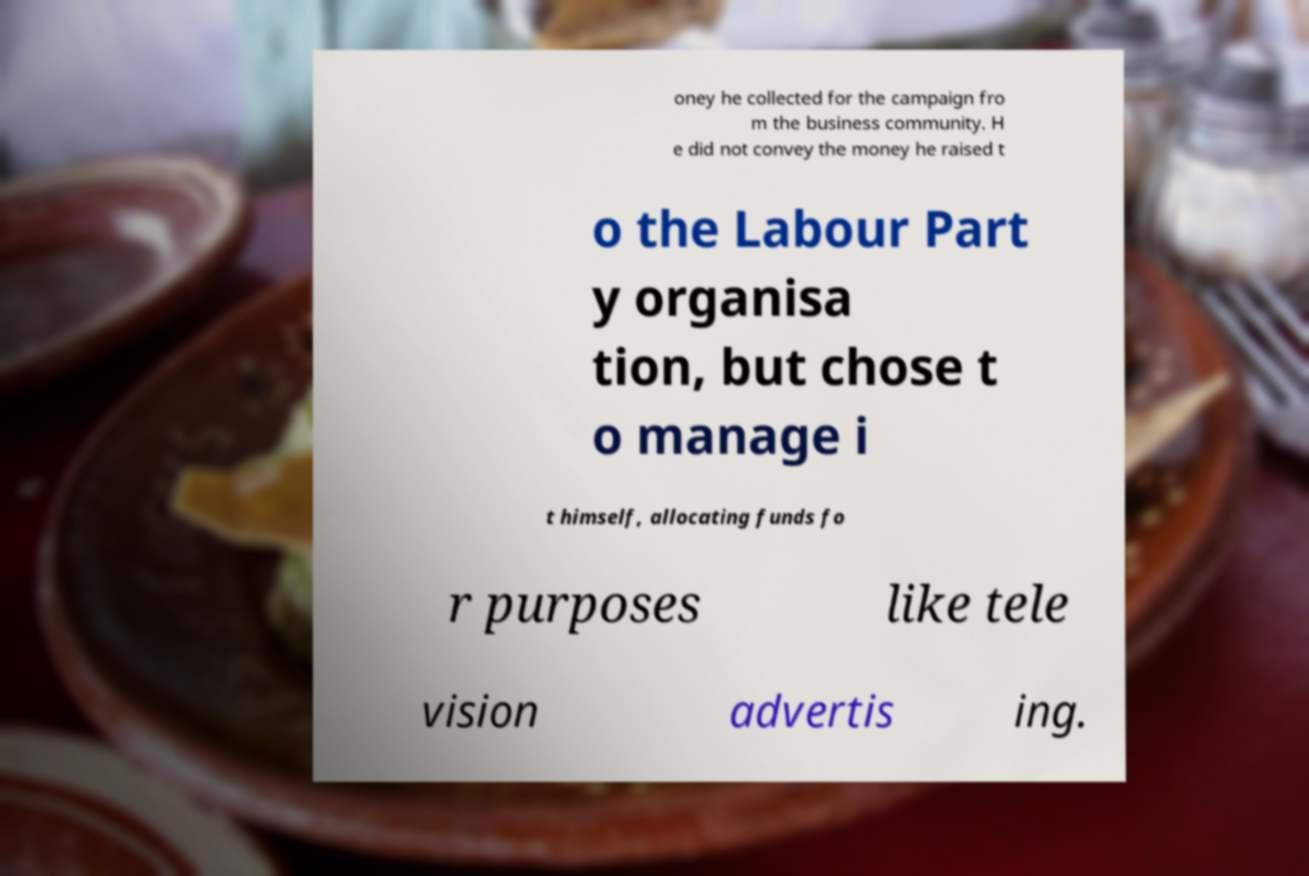Can you read and provide the text displayed in the image?This photo seems to have some interesting text. Can you extract and type it out for me? oney he collected for the campaign fro m the business community. H e did not convey the money he raised t o the Labour Part y organisa tion, but chose t o manage i t himself, allocating funds fo r purposes like tele vision advertis ing. 